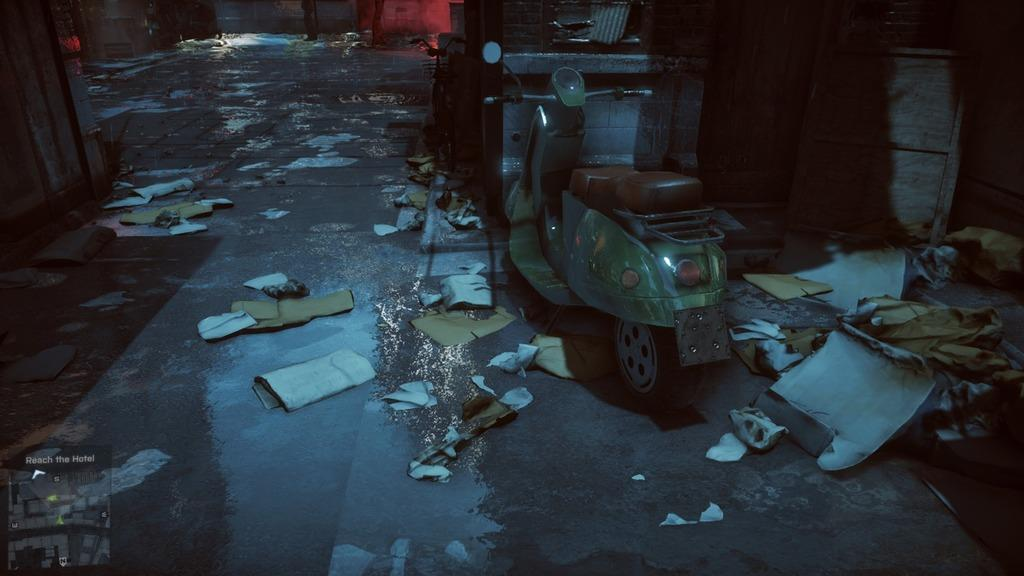What is the main subject of the image? There is a vehicle in the image. Can you describe the color of the vehicle? The vehicle is green in color. What else can be seen on the road in the image? There are papers on the road in the image. What type of jewel can be seen on the vehicle in the image? There is no jewel present on the vehicle in the image. How does the vehicle taste in the image? Vehicles do not have a taste, as they are not edible. 